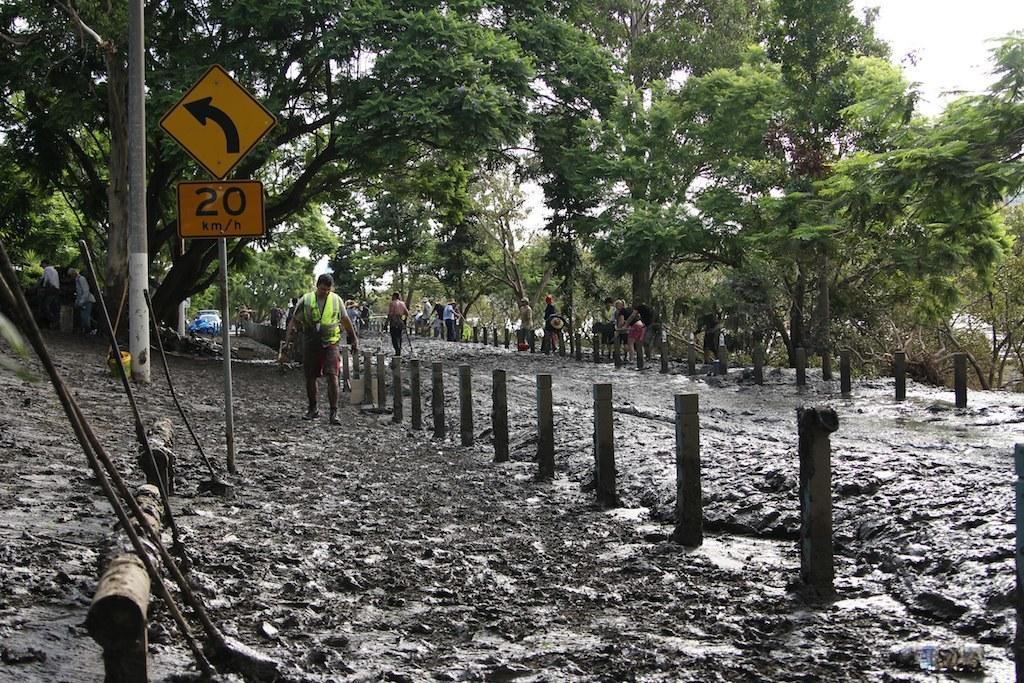Could you give a brief overview of what you see in this image? In this image we can see a sign board. In the background of the image there are trees. At the bottom of the image there is mud. There are people walking. 